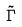Convert formula to latex. <formula><loc_0><loc_0><loc_500><loc_500>\tilde { \Gamma }</formula> 